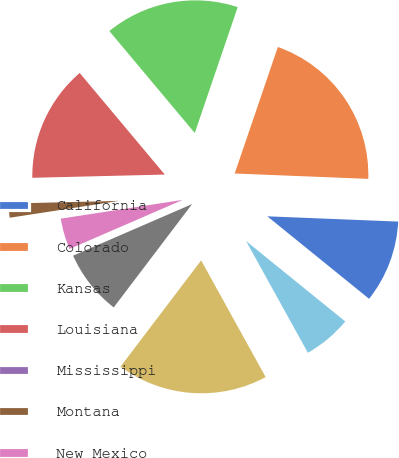Convert chart to OTSL. <chart><loc_0><loc_0><loc_500><loc_500><pie_chart><fcel>California<fcel>Colorado<fcel>Kansas<fcel>Louisiana<fcel>Mississippi<fcel>Montana<fcel>New Mexico<fcel>Oklahoma<fcel>Texas<fcel>Utah<nl><fcel>10.2%<fcel>20.41%<fcel>16.33%<fcel>14.29%<fcel>0.0%<fcel>2.04%<fcel>4.08%<fcel>8.16%<fcel>18.37%<fcel>6.12%<nl></chart> 